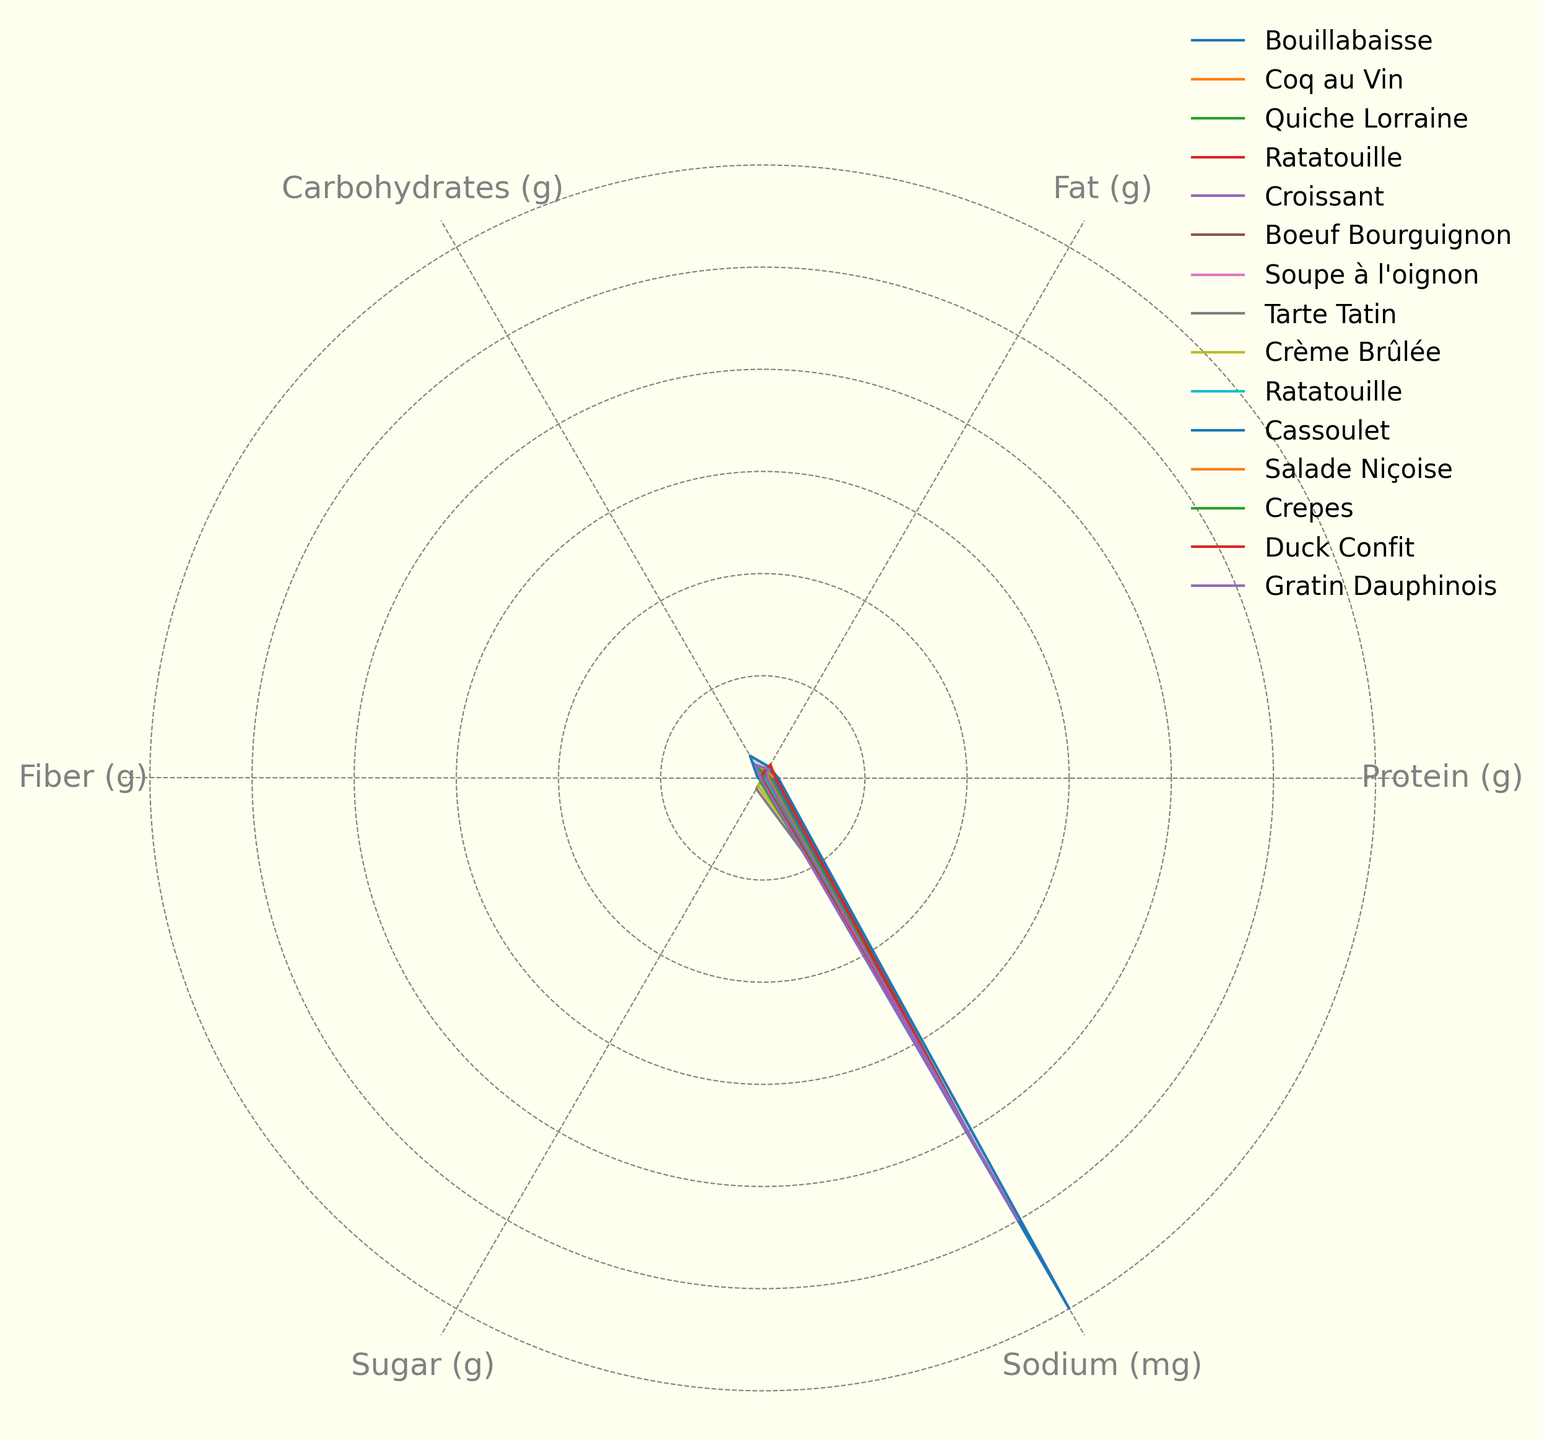Which dish has the highest fat content? Look at the petal representing "Fat (g)" for each dish and identify the one that extends the furthest from the center.
Answer: Duck Confit Which dish has the highest sodium content? Look at the petal representing "Sodium (mg)" for each dish and identify the one that extends the furthest from the center.
Answer: Cassoulet What is the difference in protein content between Coq au Vin and Soupe à l'oignon? Locate the "Protein (g)" petal for both Coq au Vin and Soupe à l'oignon and subtract the value of Soupe à l'oignon from Coq au Vin.
Answer: 21g Among the dishes with high sugar contents, which one stands out and why? Identify the petal representing "Sugar (g)" and observe the dishes with the maximum length in this petal; Tarte Tatin stands out with a significantly longer petal in "Sugar (g)" compared to others.
Answer: Tarte Tatin Which two dishes have the most similar carbohydrate contents, and what are their carbohydrate values? Compare the "Carbohydrates (g)" petal lengths for all dishes and identify the two dishes where the petal lengths are nearly the same.
Answer: Quiche Lorraine and Croissant, both with 25g What's the average fat content of Bouillabaisse, Coq au Vin, and Ratatouille? Add the "Fat (g)" values for Bouillabaisse (5g), Coq au Vin (10g), and Ratatouille (6g) and then divide by 3: (5 + 10 + 6) / 3.
Answer: 7g Which dish has the highest fiber content? Look at the "Fiber (g)" petals for all dishes; identify the one that extends the furthest from the center.
Answer: Cassoulet What is the range of protein content values across all dishes? Identify the highest and lowest "Protein (g)" petal lengths and calculate the range by subtracting the minimum value from the maximum value.
Answer: Range is 30g Which two dishes have the smallest difference in sodium content, and what is that difference? Compare the "Sodium (mg)" petals and identify the two dishes whose petal lengths in "Sodium (mg)" are closest.
Answer: Bouillabaisse and Soupe à l'oignon, difference is 50mg What's the total amount of fiber in Quiche Lorraine, Croissant, and Crème Brûlée combined? Sum the "Fiber (g)" values for Quiche Lorraine (1g), Croissant (2g), and Crème Brûlée (0g): 1 + 2 + 0.
Answer: 3g 